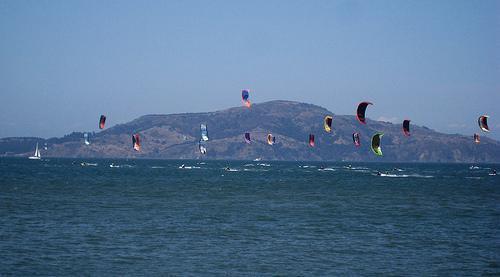How many sailboats are there?
Give a very brief answer. 1. 